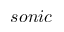Convert formula to latex. <formula><loc_0><loc_0><loc_500><loc_500>s o n i c</formula> 